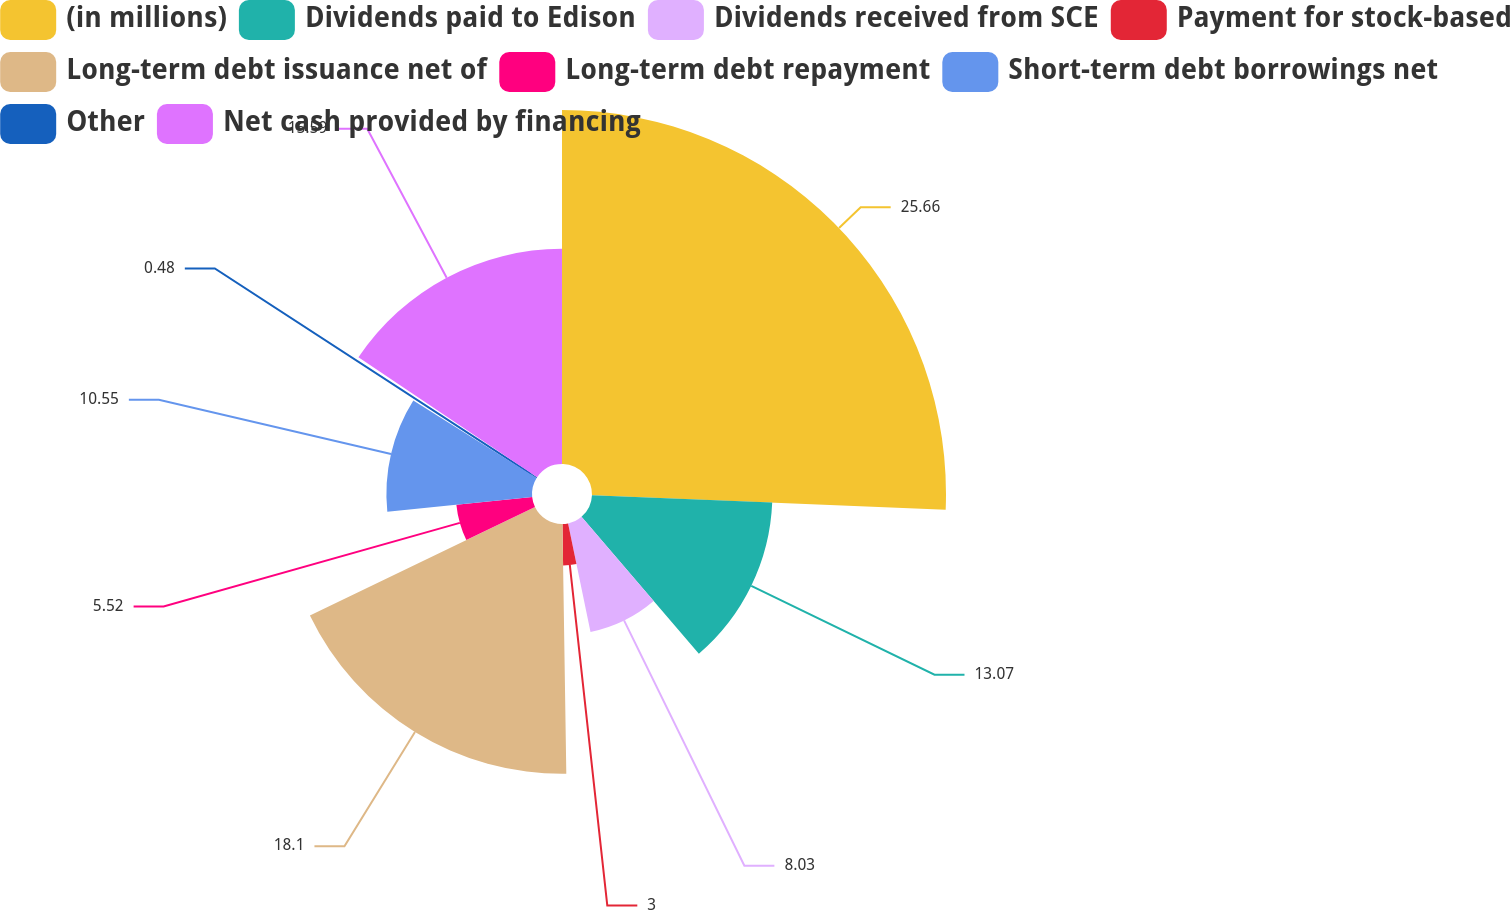Convert chart to OTSL. <chart><loc_0><loc_0><loc_500><loc_500><pie_chart><fcel>(in millions)<fcel>Dividends paid to Edison<fcel>Dividends received from SCE<fcel>Payment for stock-based<fcel>Long-term debt issuance net of<fcel>Long-term debt repayment<fcel>Short-term debt borrowings net<fcel>Other<fcel>Net cash provided by financing<nl><fcel>25.65%<fcel>13.07%<fcel>8.03%<fcel>3.0%<fcel>18.1%<fcel>5.52%<fcel>10.55%<fcel>0.48%<fcel>15.59%<nl></chart> 